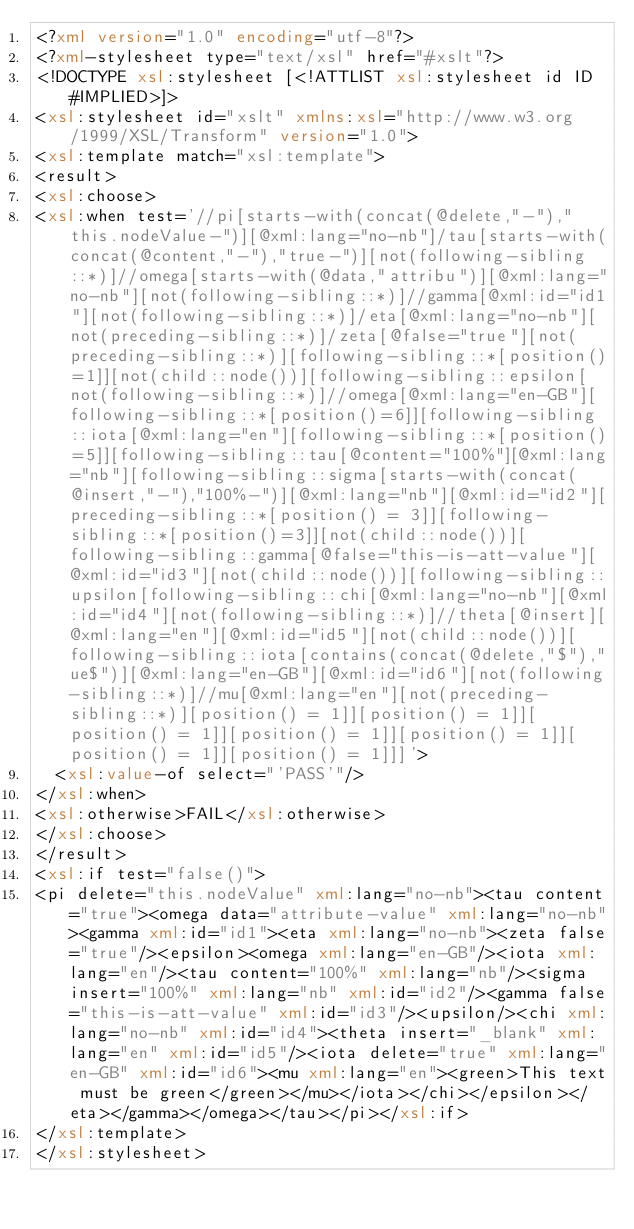Convert code to text. <code><loc_0><loc_0><loc_500><loc_500><_XML_><?xml version="1.0" encoding="utf-8"?>
<?xml-stylesheet type="text/xsl" href="#xslt"?>
<!DOCTYPE xsl:stylesheet [<!ATTLIST xsl:stylesheet id ID #IMPLIED>]>
<xsl:stylesheet id="xslt" xmlns:xsl="http://www.w3.org/1999/XSL/Transform" version="1.0">
<xsl:template match="xsl:template">
<result>
<xsl:choose>
<xsl:when test='//pi[starts-with(concat(@delete,"-"),"this.nodeValue-")][@xml:lang="no-nb"]/tau[starts-with(concat(@content,"-"),"true-")][not(following-sibling::*)]//omega[starts-with(@data,"attribu")][@xml:lang="no-nb"][not(following-sibling::*)]//gamma[@xml:id="id1"][not(following-sibling::*)]/eta[@xml:lang="no-nb"][not(preceding-sibling::*)]/zeta[@false="true"][not(preceding-sibling::*)][following-sibling::*[position()=1]][not(child::node())][following-sibling::epsilon[not(following-sibling::*)]//omega[@xml:lang="en-GB"][following-sibling::*[position()=6]][following-sibling::iota[@xml:lang="en"][following-sibling::*[position()=5]][following-sibling::tau[@content="100%"][@xml:lang="nb"][following-sibling::sigma[starts-with(concat(@insert,"-"),"100%-")][@xml:lang="nb"][@xml:id="id2"][preceding-sibling::*[position() = 3]][following-sibling::*[position()=3]][not(child::node())][following-sibling::gamma[@false="this-is-att-value"][@xml:id="id3"][not(child::node())][following-sibling::upsilon[following-sibling::chi[@xml:lang="no-nb"][@xml:id="id4"][not(following-sibling::*)]//theta[@insert][@xml:lang="en"][@xml:id="id5"][not(child::node())][following-sibling::iota[contains(concat(@delete,"$"),"ue$")][@xml:lang="en-GB"][@xml:id="id6"][not(following-sibling::*)]//mu[@xml:lang="en"][not(preceding-sibling::*)][position() = 1]][position() = 1]][position() = 1]][position() = 1]][position() = 1]][position() = 1]][position() = 1]]]'>	
	<xsl:value-of select="'PASS'"/>
</xsl:when>
<xsl:otherwise>FAIL</xsl:otherwise>
</xsl:choose>
</result>
<xsl:if test="false()">
<pi delete="this.nodeValue" xml:lang="no-nb"><tau content="true"><omega data="attribute-value" xml:lang="no-nb"><gamma xml:id="id1"><eta xml:lang="no-nb"><zeta false="true"/><epsilon><omega xml:lang="en-GB"/><iota xml:lang="en"/><tau content="100%" xml:lang="nb"/><sigma insert="100%" xml:lang="nb" xml:id="id2"/><gamma false="this-is-att-value" xml:id="id3"/><upsilon/><chi xml:lang="no-nb" xml:id="id4"><theta insert="_blank" xml:lang="en" xml:id="id5"/><iota delete="true" xml:lang="en-GB" xml:id="id6"><mu xml:lang="en"><green>This text must be green</green></mu></iota></chi></epsilon></eta></gamma></omega></tau></pi></xsl:if>
</xsl:template>
</xsl:stylesheet>
</code> 